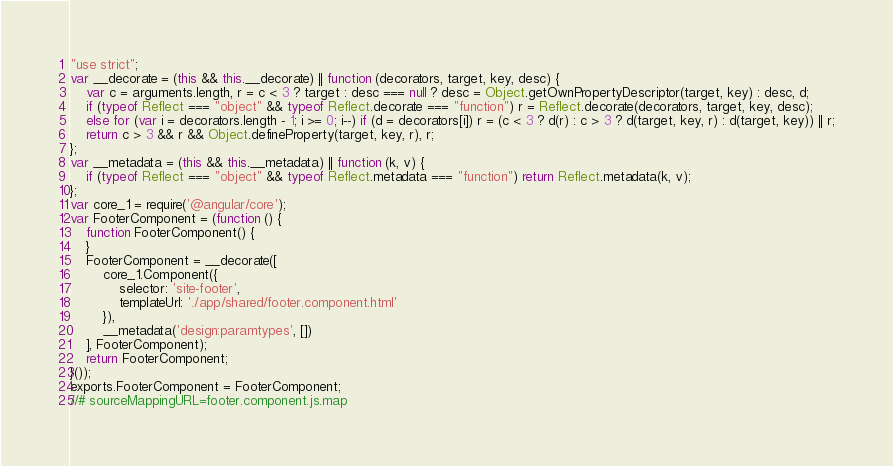<code> <loc_0><loc_0><loc_500><loc_500><_JavaScript_>"use strict";
var __decorate = (this && this.__decorate) || function (decorators, target, key, desc) {
    var c = arguments.length, r = c < 3 ? target : desc === null ? desc = Object.getOwnPropertyDescriptor(target, key) : desc, d;
    if (typeof Reflect === "object" && typeof Reflect.decorate === "function") r = Reflect.decorate(decorators, target, key, desc);
    else for (var i = decorators.length - 1; i >= 0; i--) if (d = decorators[i]) r = (c < 3 ? d(r) : c > 3 ? d(target, key, r) : d(target, key)) || r;
    return c > 3 && r && Object.defineProperty(target, key, r), r;
};
var __metadata = (this && this.__metadata) || function (k, v) {
    if (typeof Reflect === "object" && typeof Reflect.metadata === "function") return Reflect.metadata(k, v);
};
var core_1 = require('@angular/core');
var FooterComponent = (function () {
    function FooterComponent() {
    }
    FooterComponent = __decorate([
        core_1.Component({
            selector: 'site-footer',
            templateUrl: './app/shared/footer.component.html'
        }), 
        __metadata('design:paramtypes', [])
    ], FooterComponent);
    return FooterComponent;
}());
exports.FooterComponent = FooterComponent;
//# sourceMappingURL=footer.component.js.map</code> 